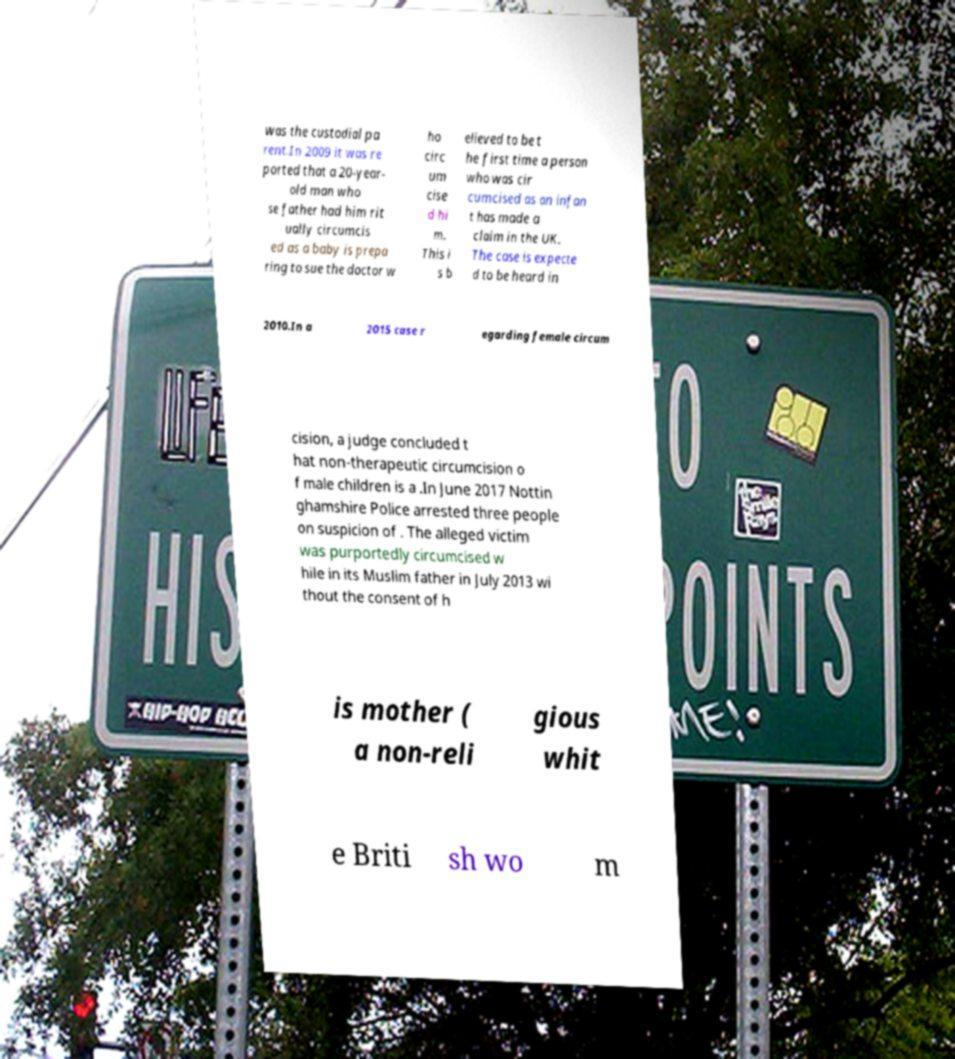There's text embedded in this image that I need extracted. Can you transcribe it verbatim? was the custodial pa rent.In 2009 it was re ported that a 20-year- old man who se father had him rit ually circumcis ed as a baby is prepa ring to sue the doctor w ho circ um cise d hi m. This i s b elieved to be t he first time a person who was cir cumcised as an infan t has made a claim in the UK. The case is expecte d to be heard in 2010.In a 2015 case r egarding female circum cision, a judge concluded t hat non-therapeutic circumcision o f male children is a .In June 2017 Nottin ghamshire Police arrested three people on suspicion of . The alleged victim was purportedly circumcised w hile in its Muslim father in July 2013 wi thout the consent of h is mother ( a non-reli gious whit e Briti sh wo m 